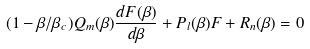Convert formula to latex. <formula><loc_0><loc_0><loc_500><loc_500>( 1 - \beta / \beta _ { c } ) Q _ { m } ( \beta ) \frac { d F ( \beta ) } { d \beta } + P _ { l } ( \beta ) F + R _ { n } ( \beta ) = 0</formula> 